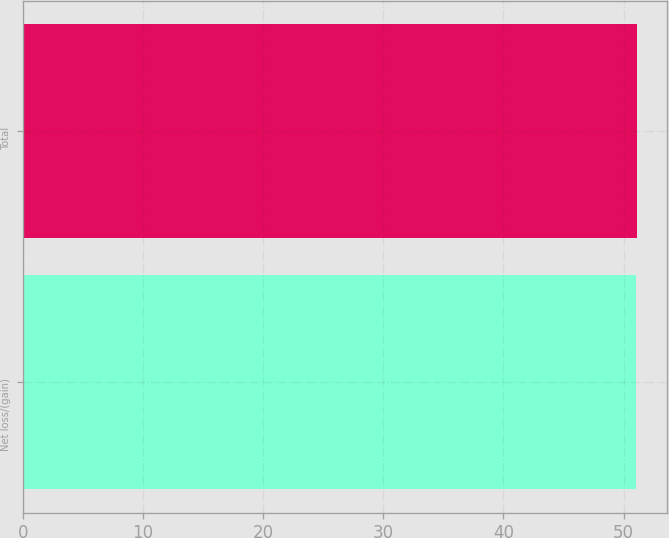Convert chart. <chart><loc_0><loc_0><loc_500><loc_500><bar_chart><fcel>Net loss/(gain)<fcel>Total<nl><fcel>51<fcel>51.1<nl></chart> 